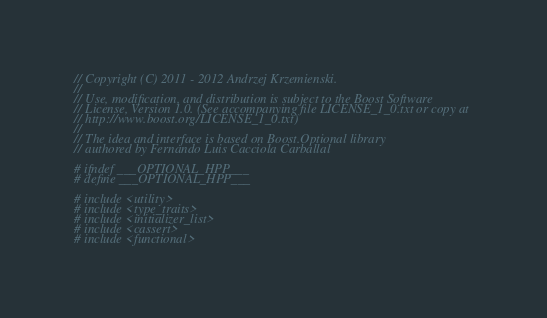<code> <loc_0><loc_0><loc_500><loc_500><_C++_>// Copyright (C) 2011 - 2012 Andrzej Krzemienski.
//
// Use, modification, and distribution is subject to the Boost Software
// License, Version 1.0. (See accompanying file LICENSE_1_0.txt or copy at
// http://www.boost.org/LICENSE_1_0.txt)
//
// The idea and interface is based on Boost.Optional library
// authored by Fernando Luis Cacciola Carballal

# ifndef ___OPTIONAL_HPP___
# define ___OPTIONAL_HPP___

# include <utility>
# include <type_traits>
# include <initializer_list>
# include <cassert>
# include <functional></code> 